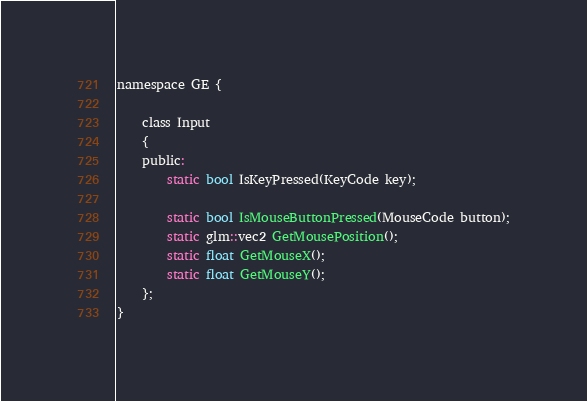Convert code to text. <code><loc_0><loc_0><loc_500><loc_500><_C_>
namespace GE {

	class Input
	{
	public:
		static bool IsKeyPressed(KeyCode key);

		static bool IsMouseButtonPressed(MouseCode button);
		static glm::vec2 GetMousePosition();
		static float GetMouseX();
		static float GetMouseY();
	};
}

</code> 